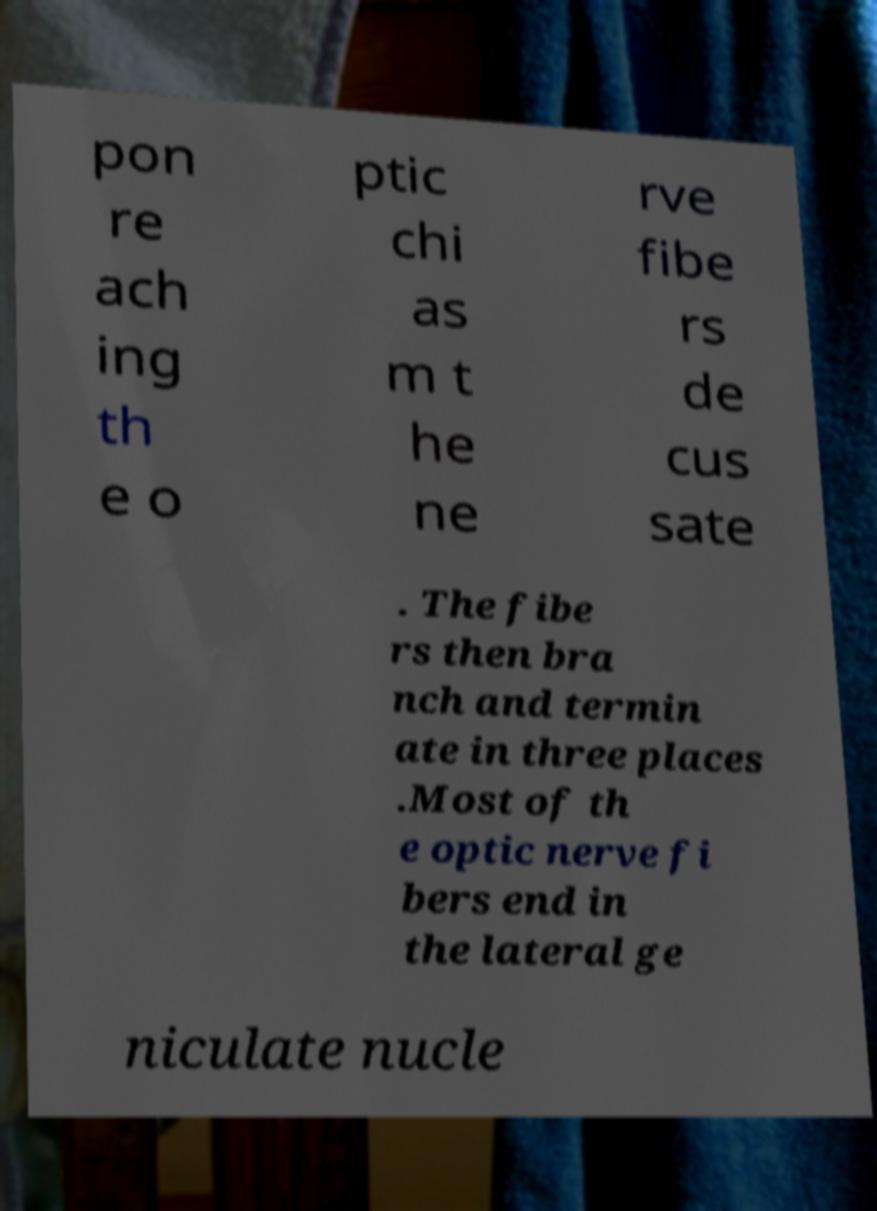Could you assist in decoding the text presented in this image and type it out clearly? pon re ach ing th e o ptic chi as m t he ne rve fibe rs de cus sate . The fibe rs then bra nch and termin ate in three places .Most of th e optic nerve fi bers end in the lateral ge niculate nucle 